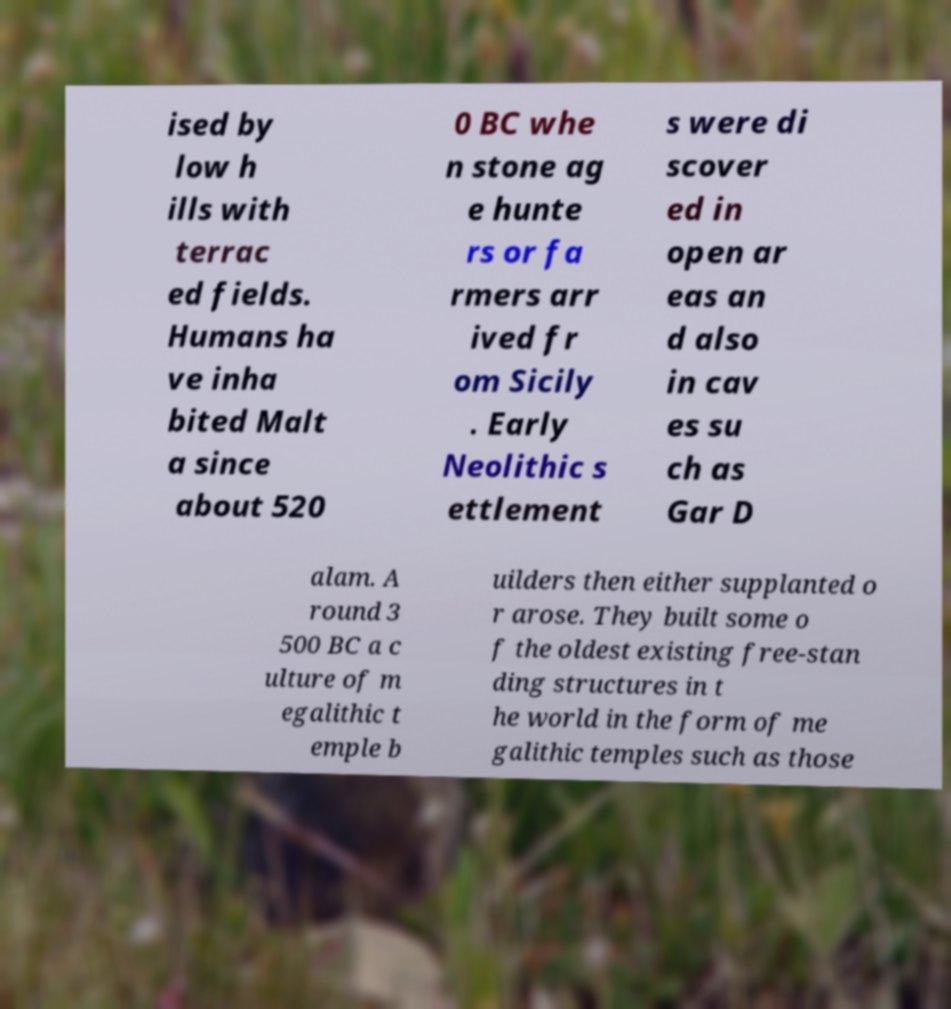Please identify and transcribe the text found in this image. ised by low h ills with terrac ed fields. Humans ha ve inha bited Malt a since about 520 0 BC whe n stone ag e hunte rs or fa rmers arr ived fr om Sicily . Early Neolithic s ettlement s were di scover ed in open ar eas an d also in cav es su ch as Gar D alam. A round 3 500 BC a c ulture of m egalithic t emple b uilders then either supplanted o r arose. They built some o f the oldest existing free-stan ding structures in t he world in the form of me galithic temples such as those 